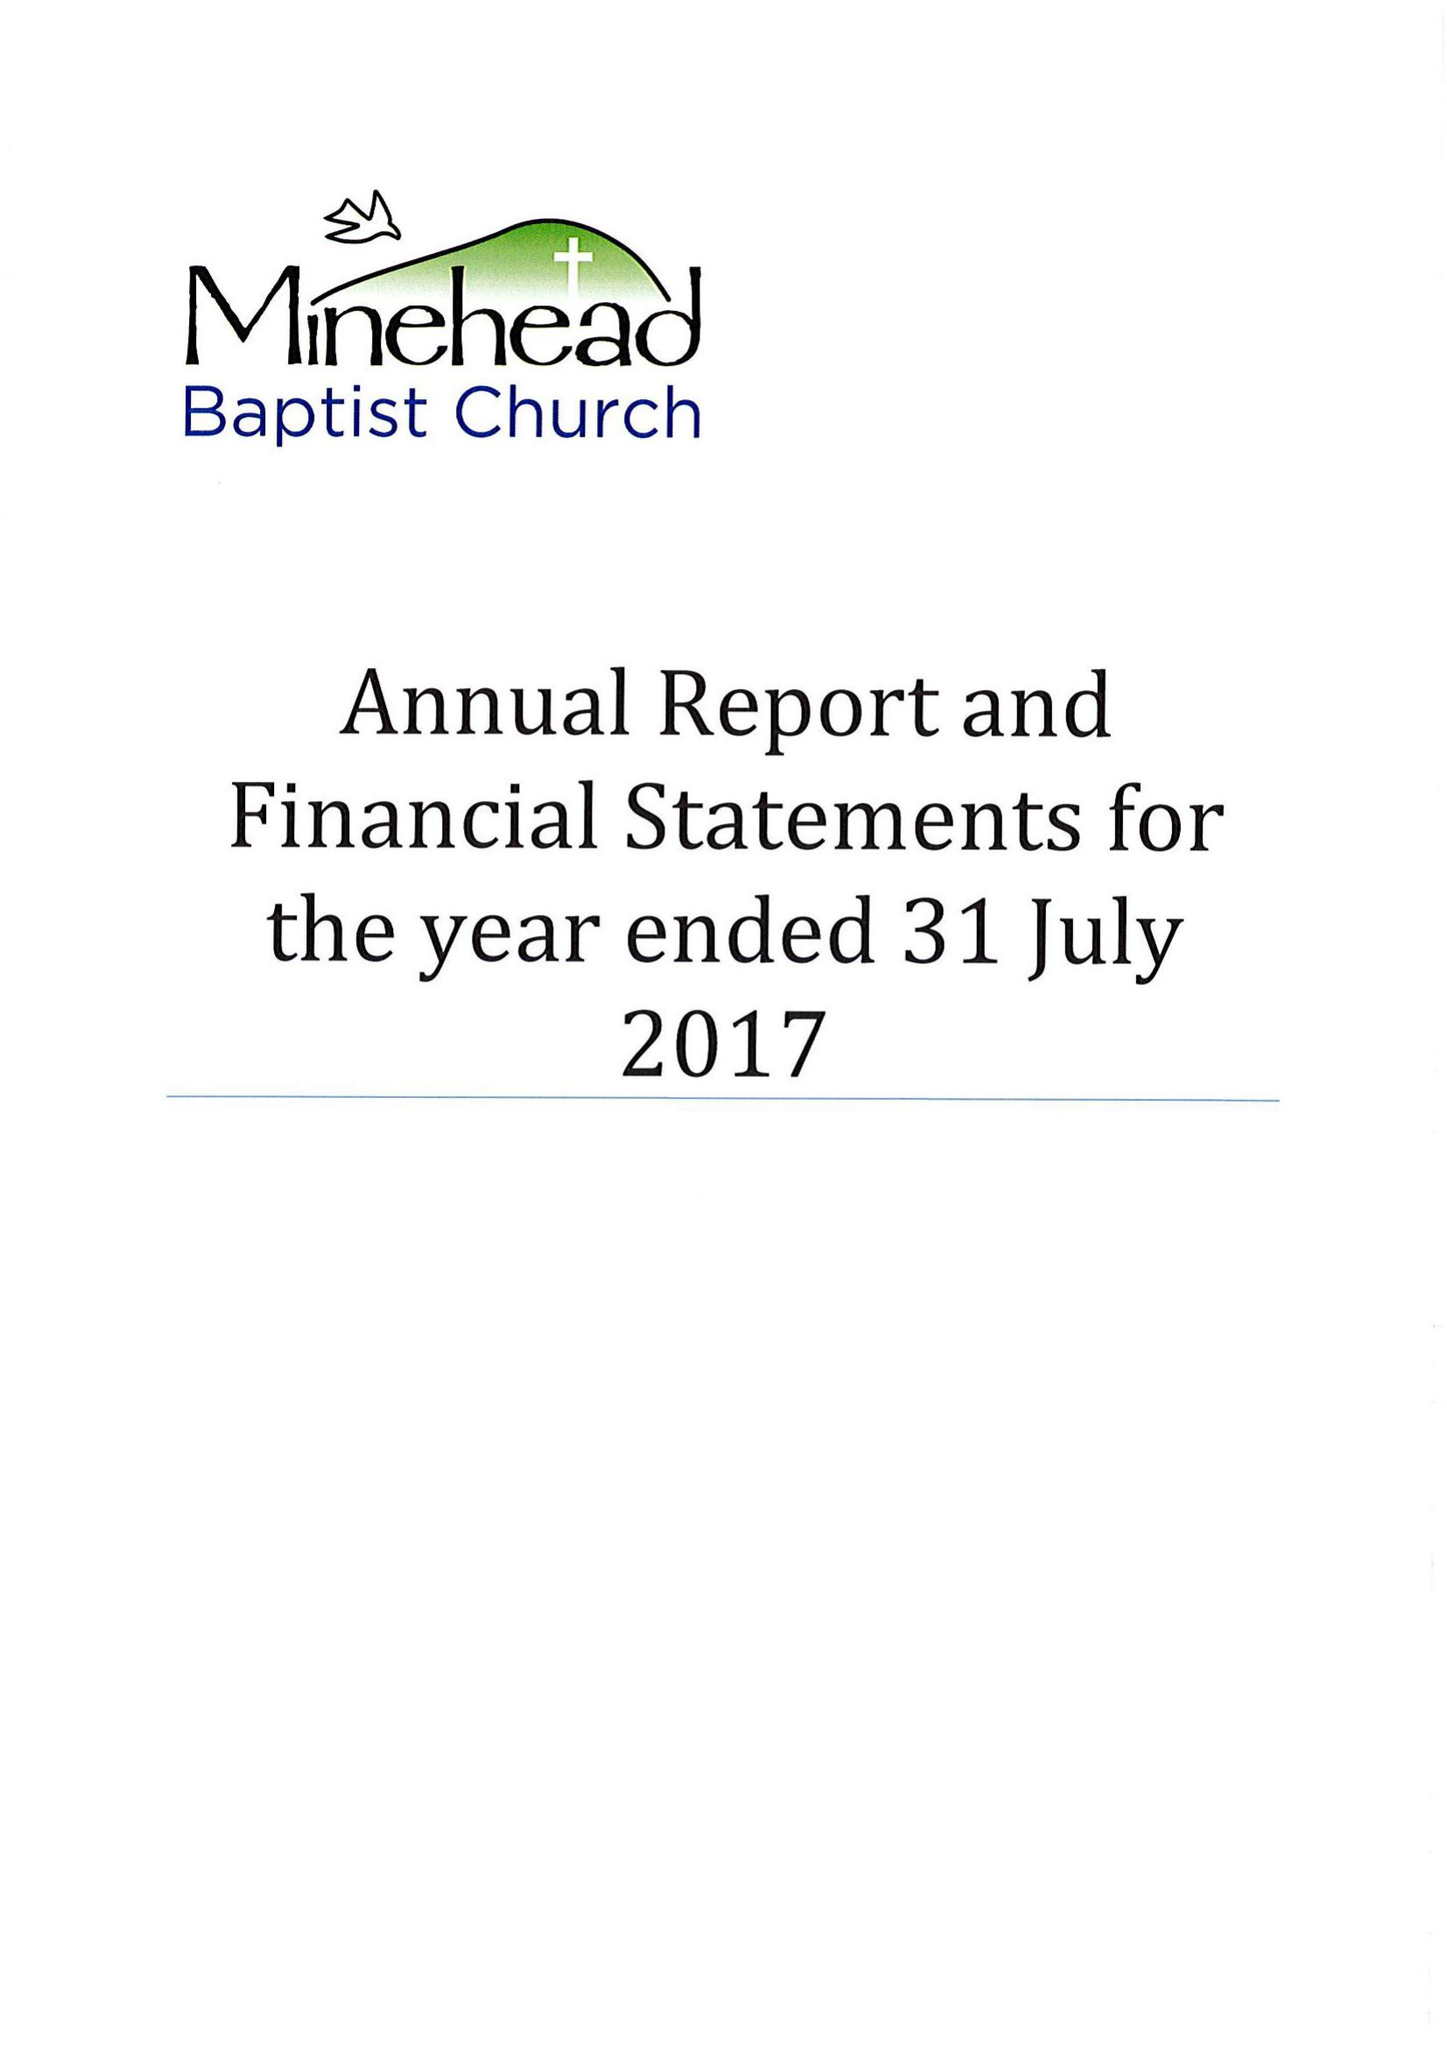What is the value for the address__postcode?
Answer the question using a single word or phrase. TA24 8BS 